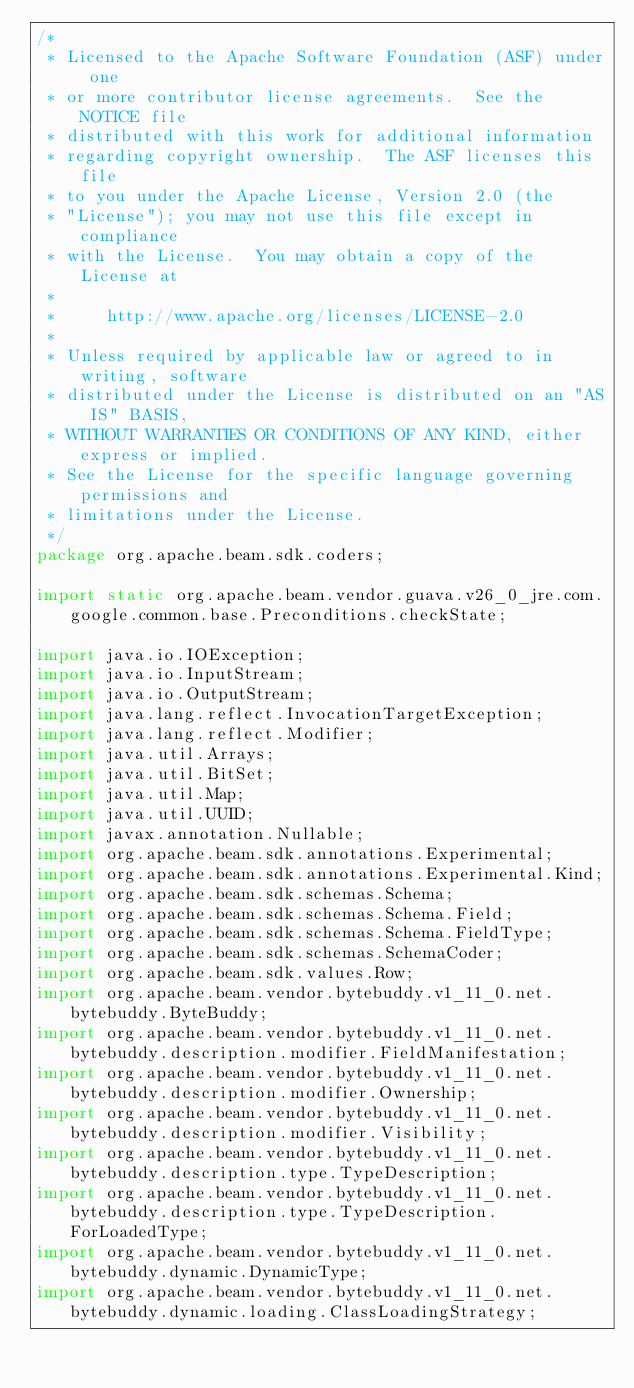<code> <loc_0><loc_0><loc_500><loc_500><_Java_>/*
 * Licensed to the Apache Software Foundation (ASF) under one
 * or more contributor license agreements.  See the NOTICE file
 * distributed with this work for additional information
 * regarding copyright ownership.  The ASF licenses this file
 * to you under the Apache License, Version 2.0 (the
 * "License"); you may not use this file except in compliance
 * with the License.  You may obtain a copy of the License at
 *
 *     http://www.apache.org/licenses/LICENSE-2.0
 *
 * Unless required by applicable law or agreed to in writing, software
 * distributed under the License is distributed on an "AS IS" BASIS,
 * WITHOUT WARRANTIES OR CONDITIONS OF ANY KIND, either express or implied.
 * See the License for the specific language governing permissions and
 * limitations under the License.
 */
package org.apache.beam.sdk.coders;

import static org.apache.beam.vendor.guava.v26_0_jre.com.google.common.base.Preconditions.checkState;

import java.io.IOException;
import java.io.InputStream;
import java.io.OutputStream;
import java.lang.reflect.InvocationTargetException;
import java.lang.reflect.Modifier;
import java.util.Arrays;
import java.util.BitSet;
import java.util.Map;
import java.util.UUID;
import javax.annotation.Nullable;
import org.apache.beam.sdk.annotations.Experimental;
import org.apache.beam.sdk.annotations.Experimental.Kind;
import org.apache.beam.sdk.schemas.Schema;
import org.apache.beam.sdk.schemas.Schema.Field;
import org.apache.beam.sdk.schemas.Schema.FieldType;
import org.apache.beam.sdk.schemas.SchemaCoder;
import org.apache.beam.sdk.values.Row;
import org.apache.beam.vendor.bytebuddy.v1_11_0.net.bytebuddy.ByteBuddy;
import org.apache.beam.vendor.bytebuddy.v1_11_0.net.bytebuddy.description.modifier.FieldManifestation;
import org.apache.beam.vendor.bytebuddy.v1_11_0.net.bytebuddy.description.modifier.Ownership;
import org.apache.beam.vendor.bytebuddy.v1_11_0.net.bytebuddy.description.modifier.Visibility;
import org.apache.beam.vendor.bytebuddy.v1_11_0.net.bytebuddy.description.type.TypeDescription;
import org.apache.beam.vendor.bytebuddy.v1_11_0.net.bytebuddy.description.type.TypeDescription.ForLoadedType;
import org.apache.beam.vendor.bytebuddy.v1_11_0.net.bytebuddy.dynamic.DynamicType;
import org.apache.beam.vendor.bytebuddy.v1_11_0.net.bytebuddy.dynamic.loading.ClassLoadingStrategy;</code> 